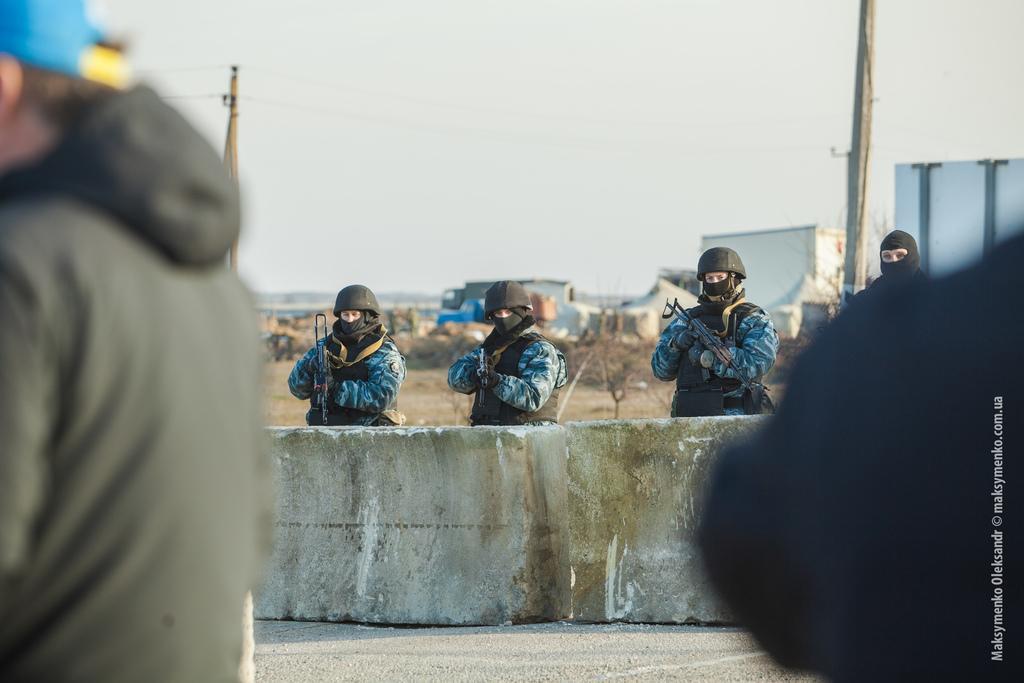Can you describe this image briefly? In this image we can see the people wearing the uniforms and also the helmets and holding the weapons and standing. We can also see a man on the left. We can see the barrier, road, electrical poles, wires and also the sky in the background. On the right we can see the text. 